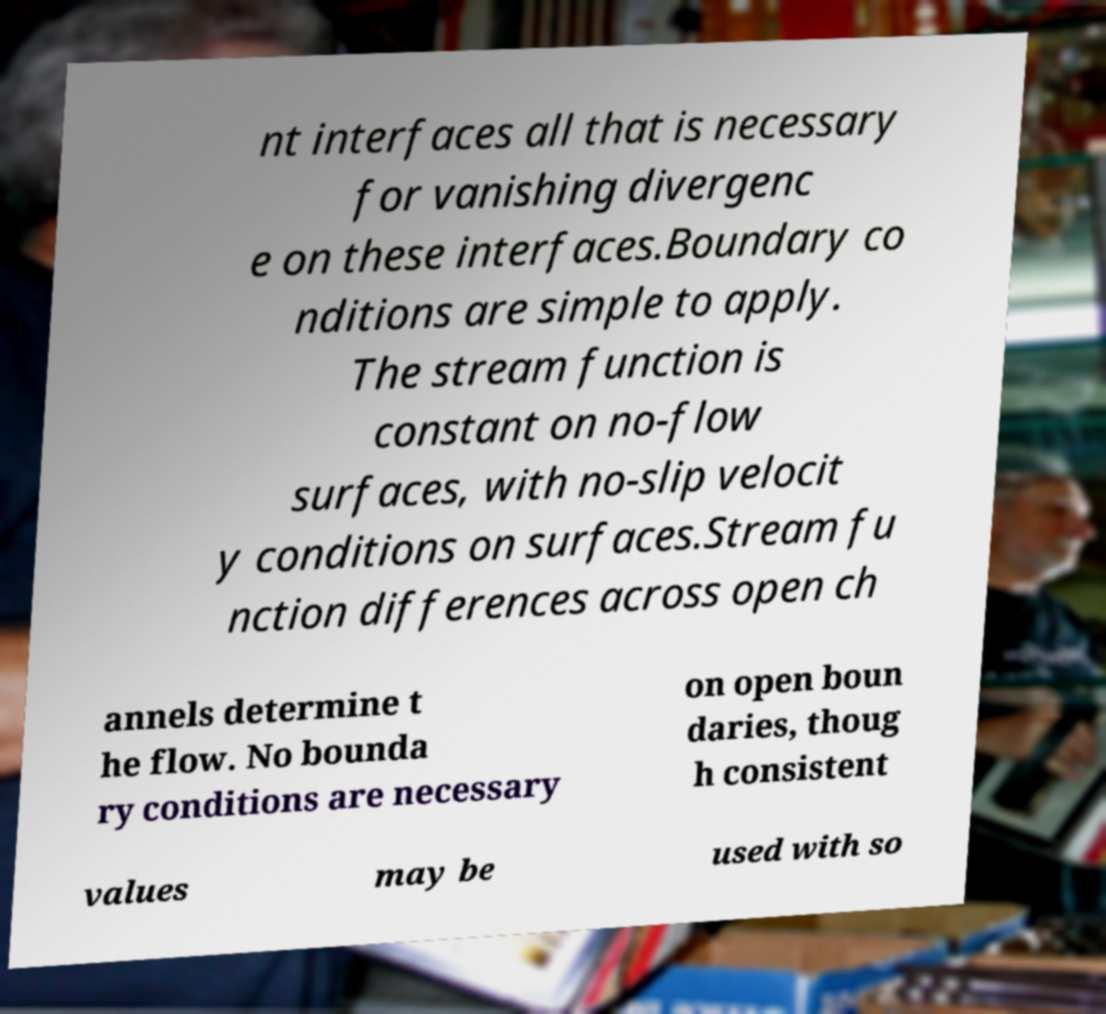There's text embedded in this image that I need extracted. Can you transcribe it verbatim? nt interfaces all that is necessary for vanishing divergenc e on these interfaces.Boundary co nditions are simple to apply. The stream function is constant on no-flow surfaces, with no-slip velocit y conditions on surfaces.Stream fu nction differences across open ch annels determine t he flow. No bounda ry conditions are necessary on open boun daries, thoug h consistent values may be used with so 